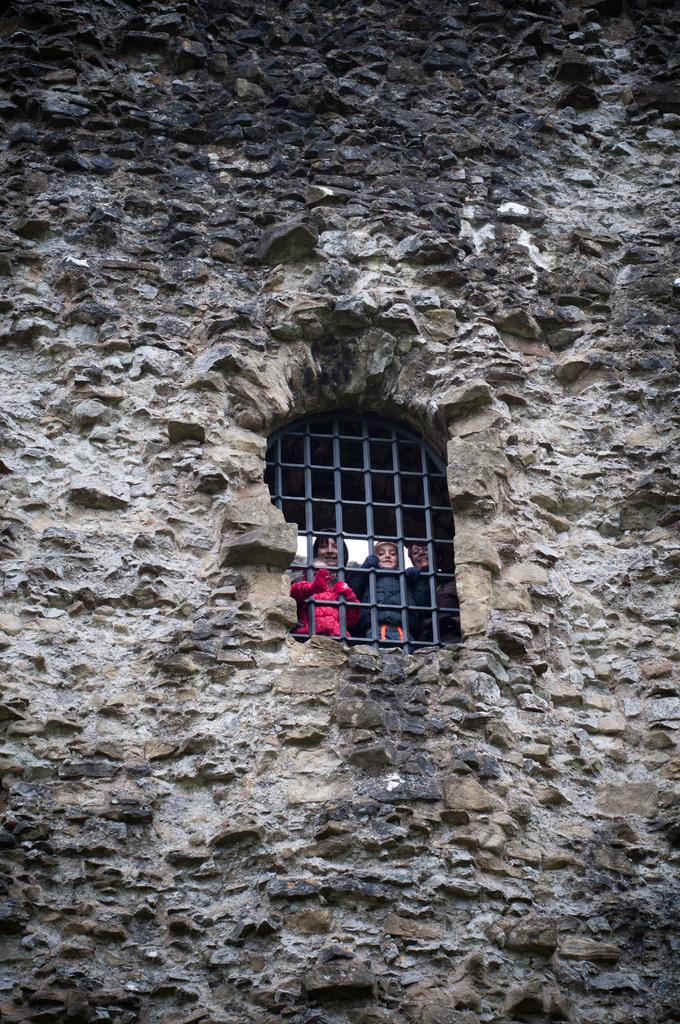What is present in the image that separates spaces? There is a wall in the image. Can you describe what is visible on the other side of the wall? People are visible through a grille in the image. What type of hat is the person wearing in the image? There is no hat visible in the image; only people are visible through the grille. 